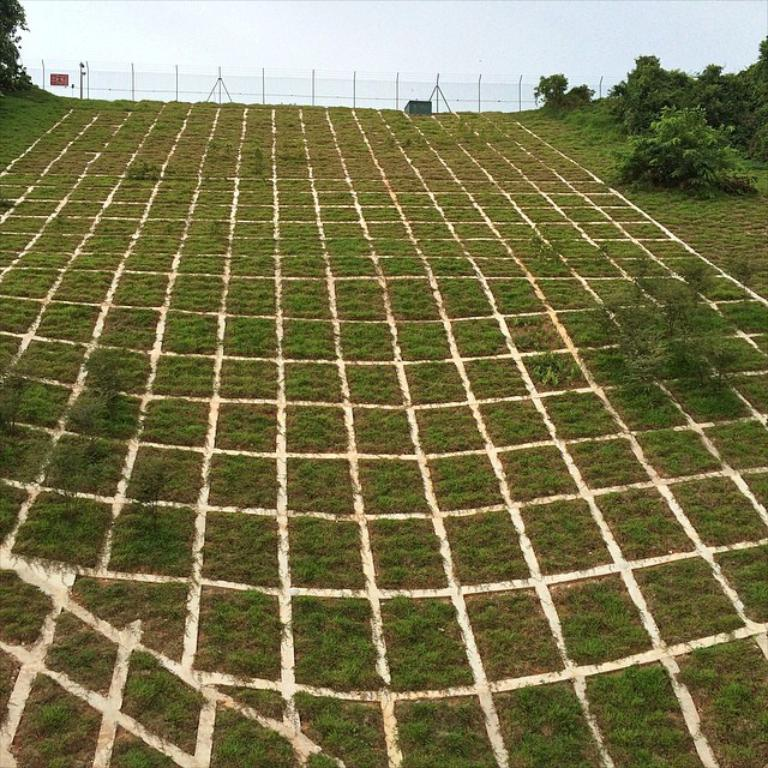What type of vegetation is present on the ground in the image? There is grass on the ground in the image. What other types of vegetation can be seen in the image? There are green plants and trees in the image. What is the purpose of the structure visible in the image? The fence in the image serves as a barrier or boundary. What is visible at the top of the image? The sky is visible at the top of the image. How many babies were born during the rainstorm depicted in the image? There is no rainstorm or any indication of a birth event in the image. 